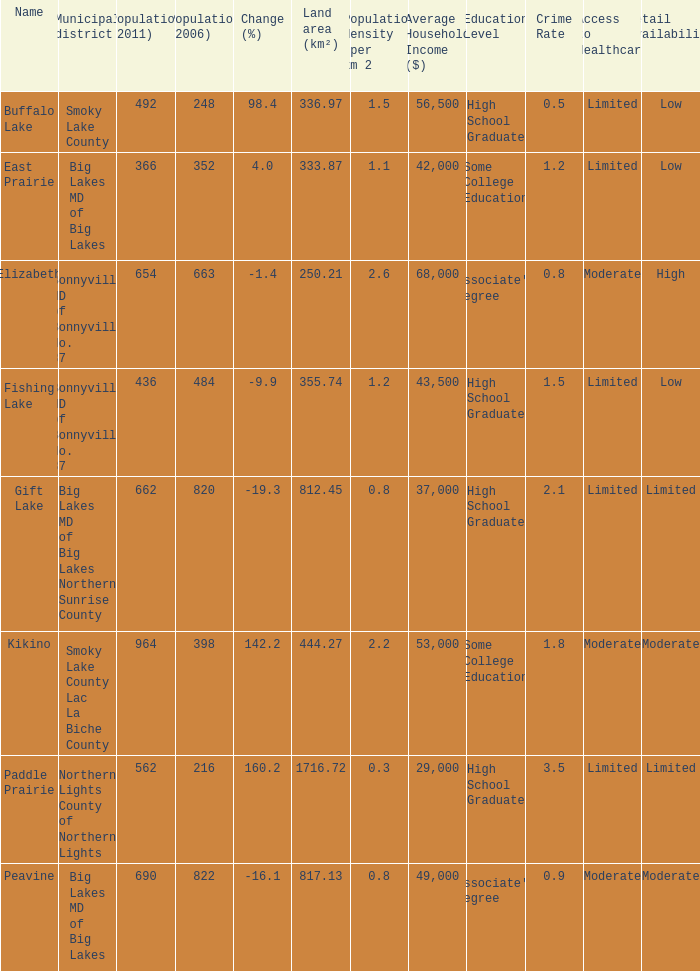What is the population per km2 in Fishing Lake? 1.2. 